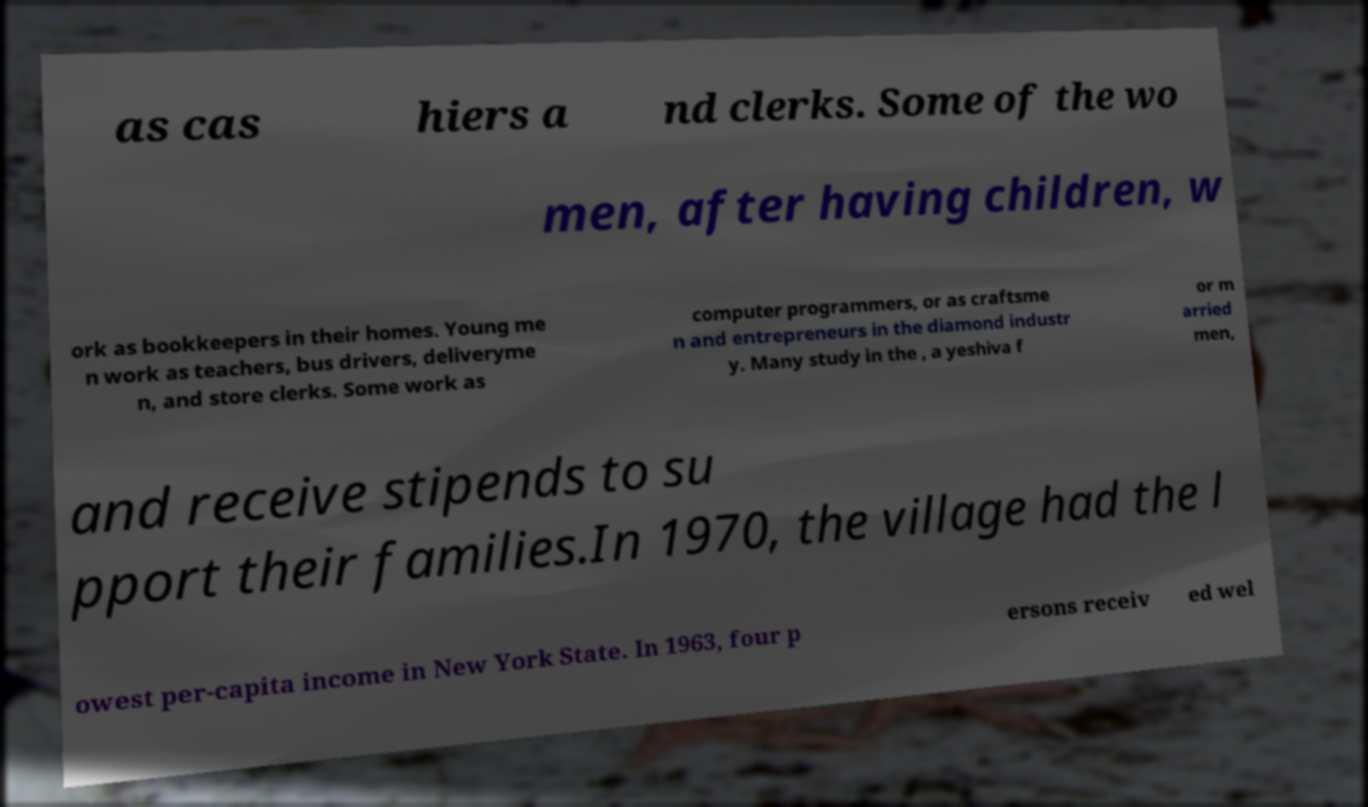There's text embedded in this image that I need extracted. Can you transcribe it verbatim? as cas hiers a nd clerks. Some of the wo men, after having children, w ork as bookkeepers in their homes. Young me n work as teachers, bus drivers, deliveryme n, and store clerks. Some work as computer programmers, or as craftsme n and entrepreneurs in the diamond industr y. Many study in the , a yeshiva f or m arried men, and receive stipends to su pport their families.In 1970, the village had the l owest per-capita income in New York State. In 1963, four p ersons receiv ed wel 